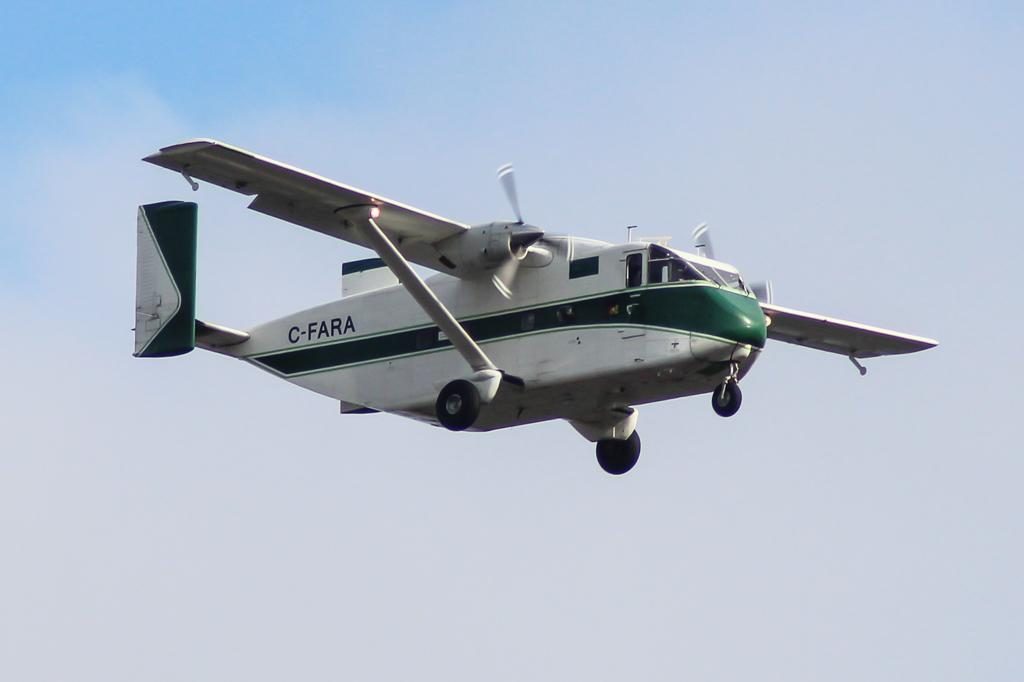Provide a one-sentence caption for the provided image. A white airplane with a green stripe is flying with C-FARA near the tail. 